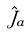<formula> <loc_0><loc_0><loc_500><loc_500>\hat { J } _ { a }</formula> 